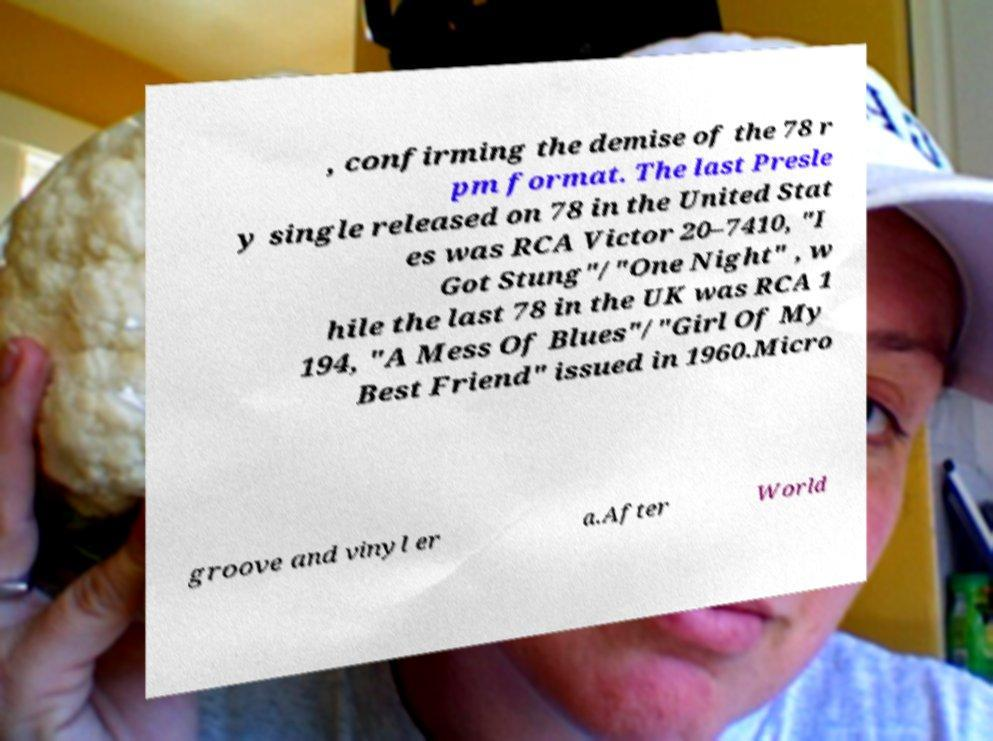Can you accurately transcribe the text from the provided image for me? , confirming the demise of the 78 r pm format. The last Presle y single released on 78 in the United Stat es was RCA Victor 20–7410, "I Got Stung"/"One Night" , w hile the last 78 in the UK was RCA 1 194, "A Mess Of Blues"/"Girl Of My Best Friend" issued in 1960.Micro groove and vinyl er a.After World 